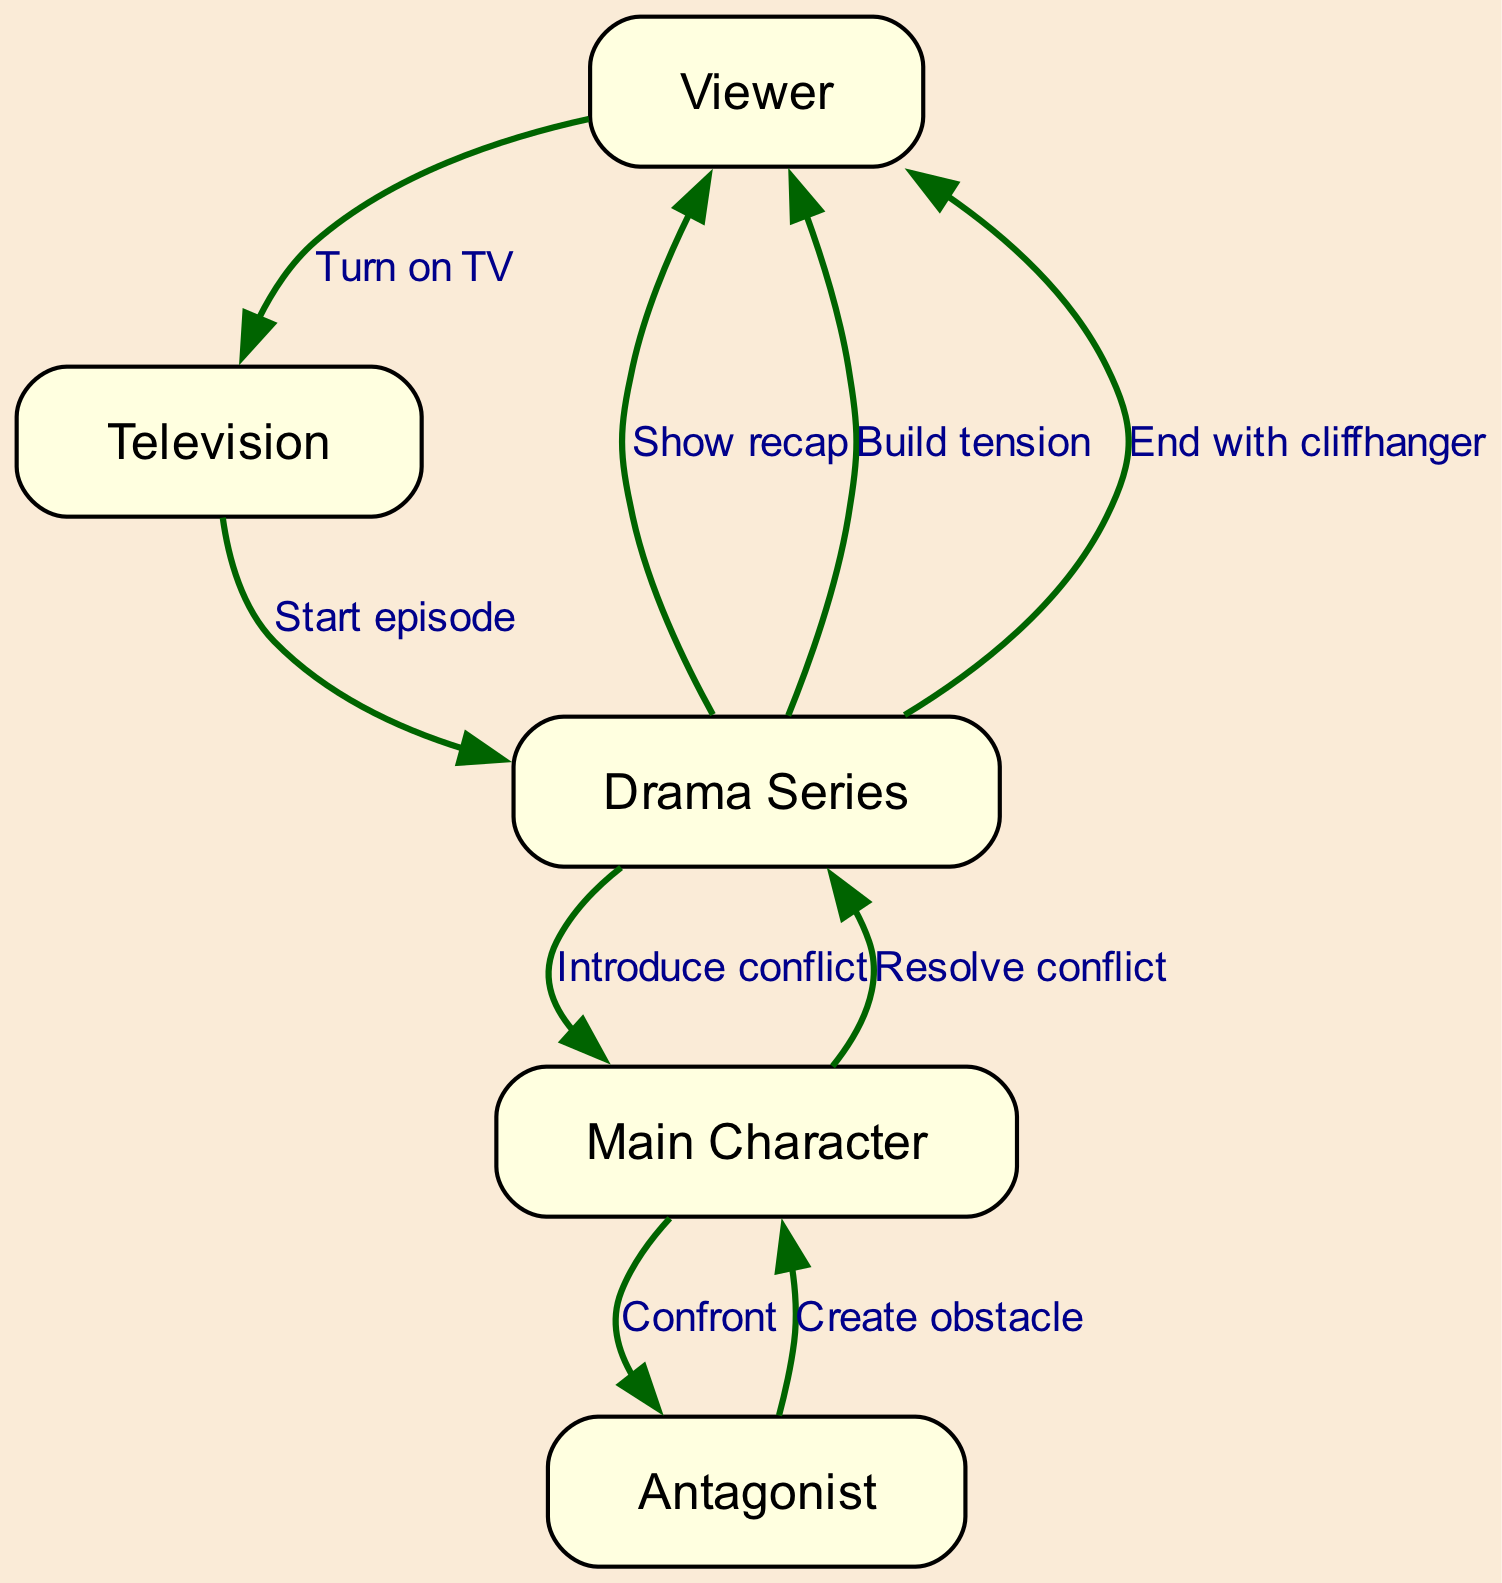What is the first action in the diagram? The diagram starts with the action "Turn on TV" initiated by the Viewer, indicating the very first step that triggers the sequence of events in the drama series.
Answer: Turn on TV How many actors are in the sequence diagram? There are five actors represented in the diagram: Viewer, Television, Drama Series, Main Character, and Antagonist. This gives a clear indication of all the characters involved in the sequence.
Answer: Five Which actor shows the recap to the Viewer? The event "Show recap" is performed by the Drama Series, indicating that it is the entity responsible for presenting the recap to the Viewer after starting the episode.
Answer: Drama Series What action does the Antagonist take towards the Main Character? The Antagonist creates an obstacle for the Main Character, signifying the conflict introduced in the plot. This establishes the opposition necessary for the narrative.
Answer: Create obstacle What happens after the Main Character confronts the Antagonist? After the Main Character confronts the Antagonist, the next event in the diagram indicates that "Build tension" happens, demonstrating an escalation in the storyline immediately following the confrontation to amplify suspense.
Answer: Build tension Which event concludes the episode? The final action in the diagram is "End with cliffhanger," signaling that the episode concludes on a suspenseful note, leaving viewers eager for the next episode.
Answer: End with cliffhanger What is the relationship between the Main Character and the Antagonist? The relationship depicted is confrontational, as indicated by the action "Confront," showing the direct conflict present between these two key characters in the drama.
Answer: Confront How many events are there in the sequence? The sequence comprises eight distinct events, showcasing the various interactions and developments occurring in the episode as it progresses.
Answer: Eight What action follows the introduction of conflict? Following the action of "Introduce conflict," the Antagonist then "Create obstacle," representing a sequential development where the conflict escalates to complicate the Main Character's situation.
Answer: Create obstacle 